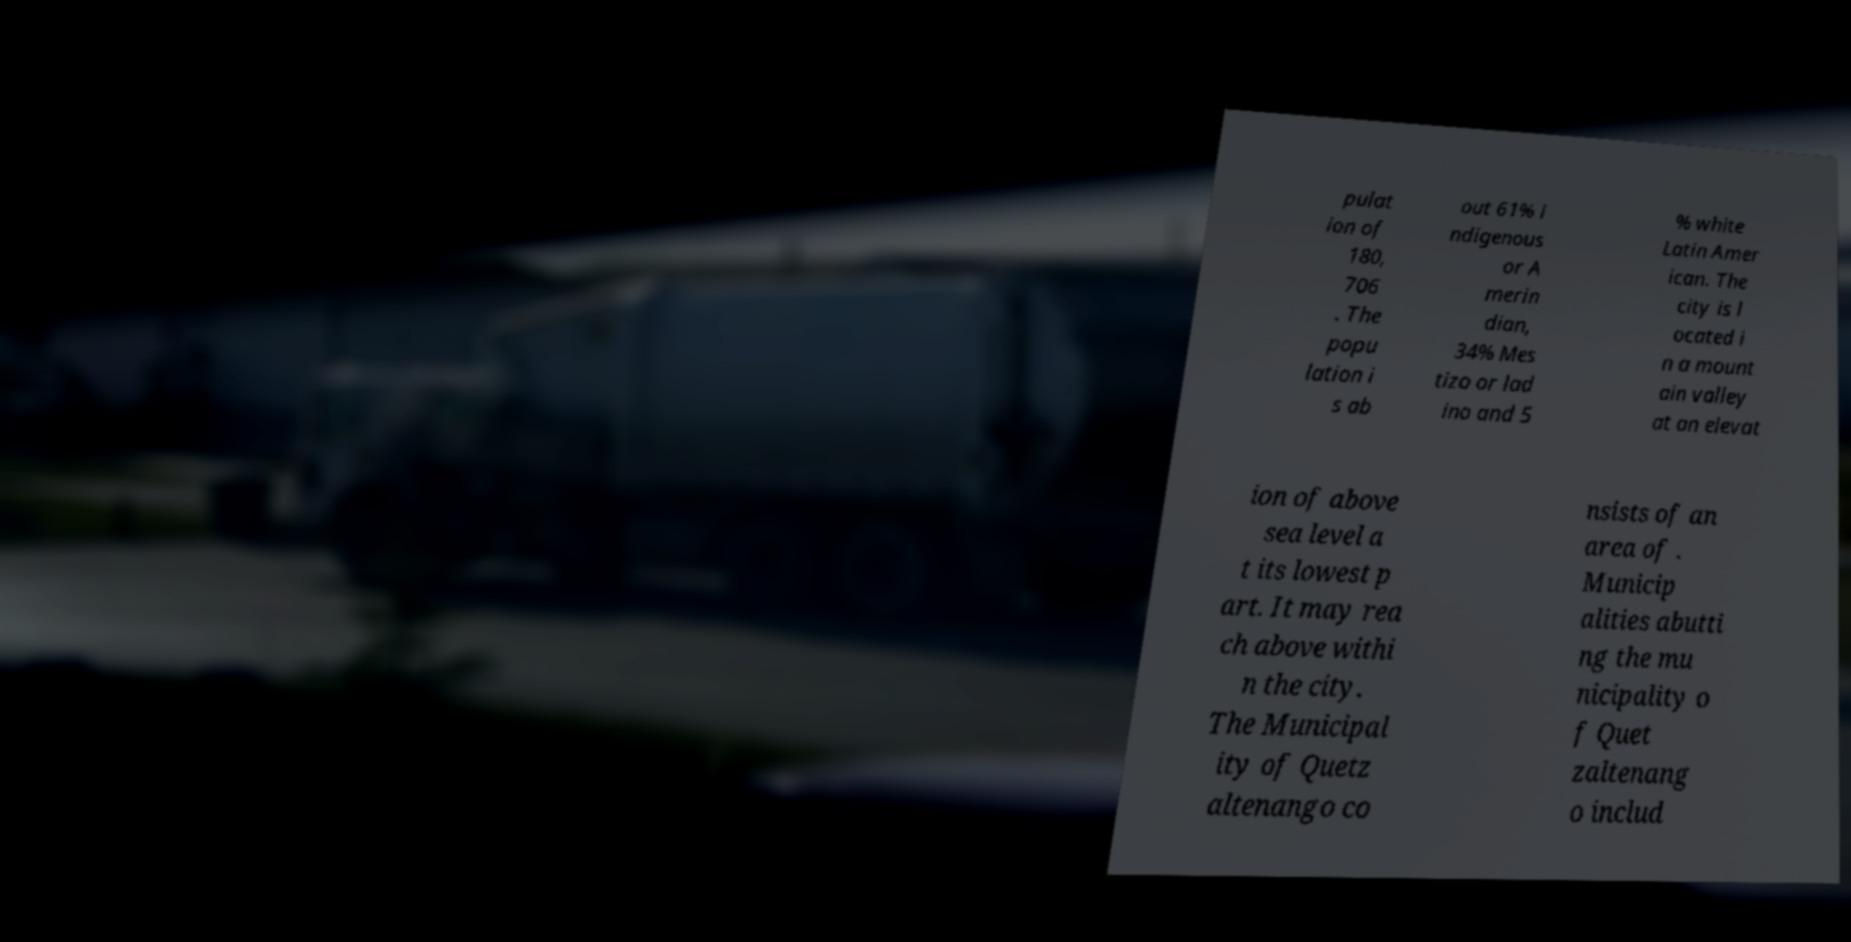Can you read and provide the text displayed in the image?This photo seems to have some interesting text. Can you extract and type it out for me? pulat ion of 180, 706 . The popu lation i s ab out 61% i ndigenous or A merin dian, 34% Mes tizo or lad ino and 5 % white Latin Amer ican. The city is l ocated i n a mount ain valley at an elevat ion of above sea level a t its lowest p art. It may rea ch above withi n the city. The Municipal ity of Quetz altenango co nsists of an area of . Municip alities abutti ng the mu nicipality o f Quet zaltenang o includ 